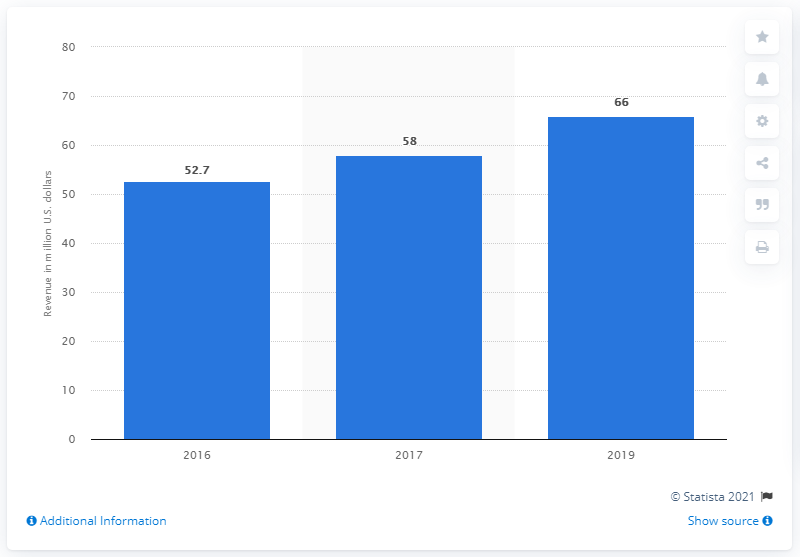Identify some key points in this picture. Fitness Formula Clubs generated approximately 66 million dollars in revenue in 2019. 